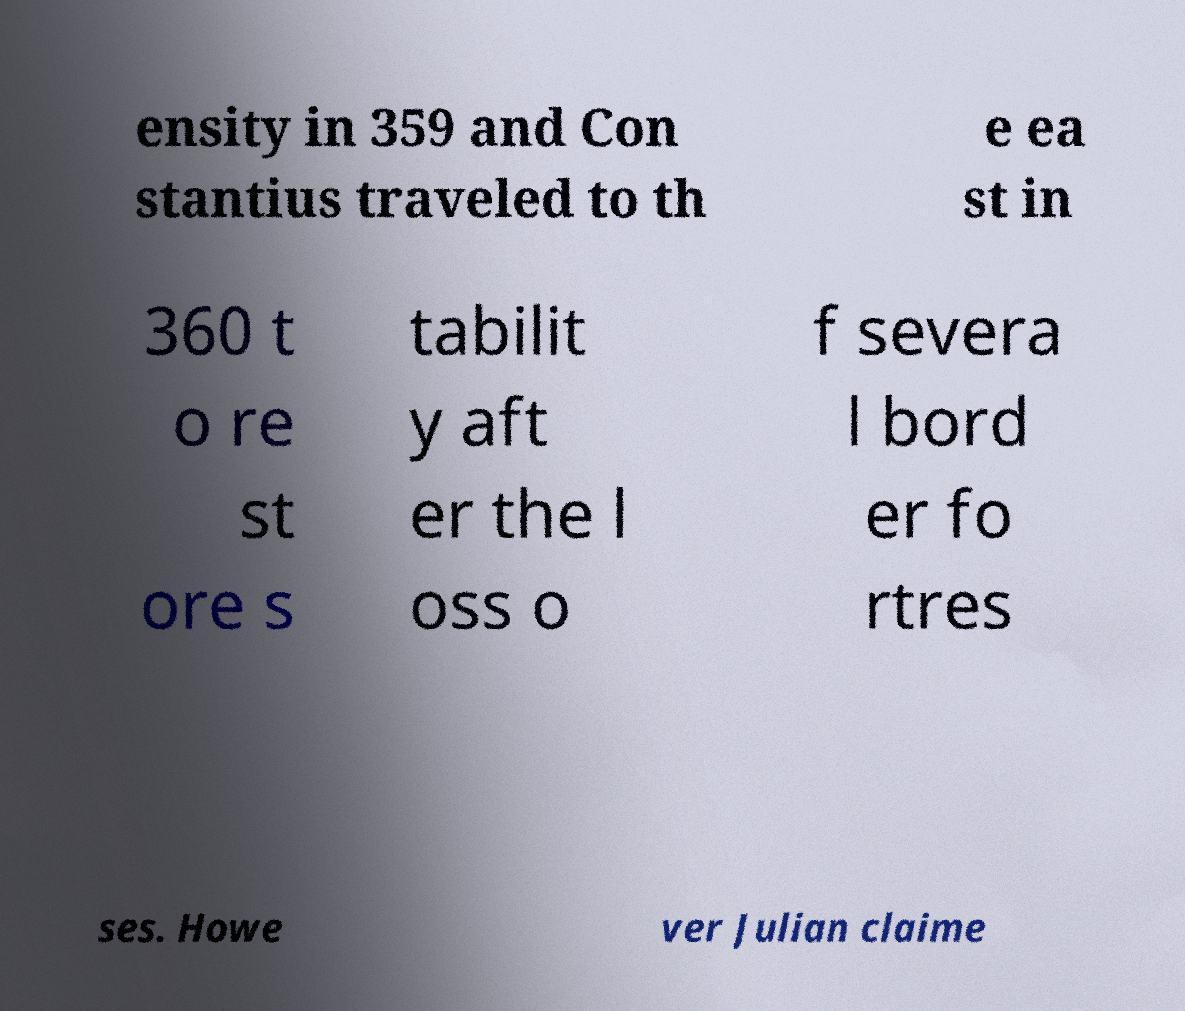For documentation purposes, I need the text within this image transcribed. Could you provide that? ensity in 359 and Con stantius traveled to th e ea st in 360 t o re st ore s tabilit y aft er the l oss o f severa l bord er fo rtres ses. Howe ver Julian claime 